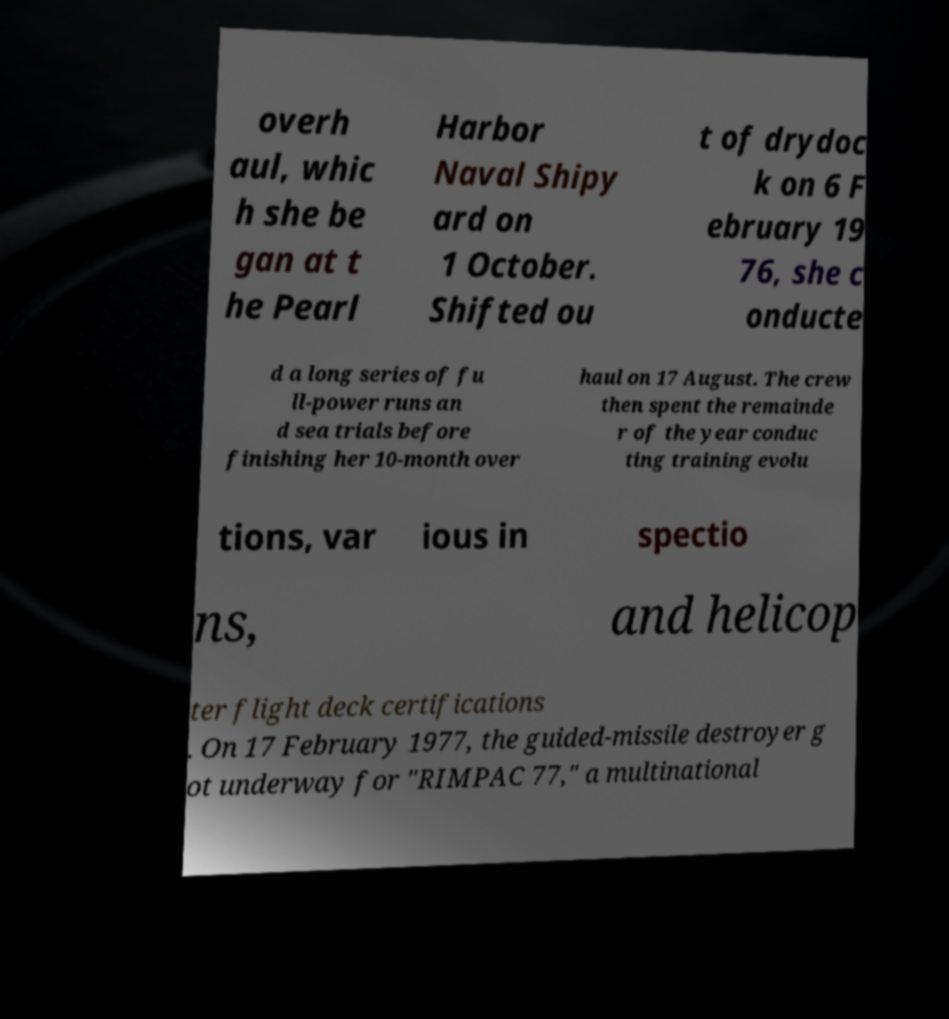What messages or text are displayed in this image? I need them in a readable, typed format. overh aul, whic h she be gan at t he Pearl Harbor Naval Shipy ard on 1 October. Shifted ou t of drydoc k on 6 F ebruary 19 76, she c onducte d a long series of fu ll-power runs an d sea trials before finishing her 10-month over haul on 17 August. The crew then spent the remainde r of the year conduc ting training evolu tions, var ious in spectio ns, and helicop ter flight deck certifications . On 17 February 1977, the guided-missile destroyer g ot underway for "RIMPAC 77," a multinational 